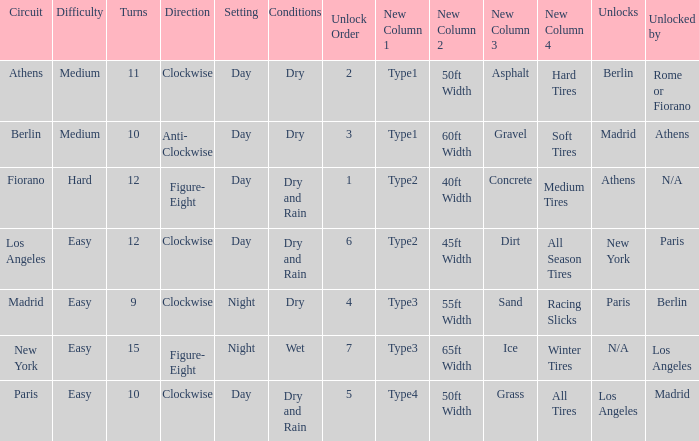What are the conditions for the athens circuit? Dry. 